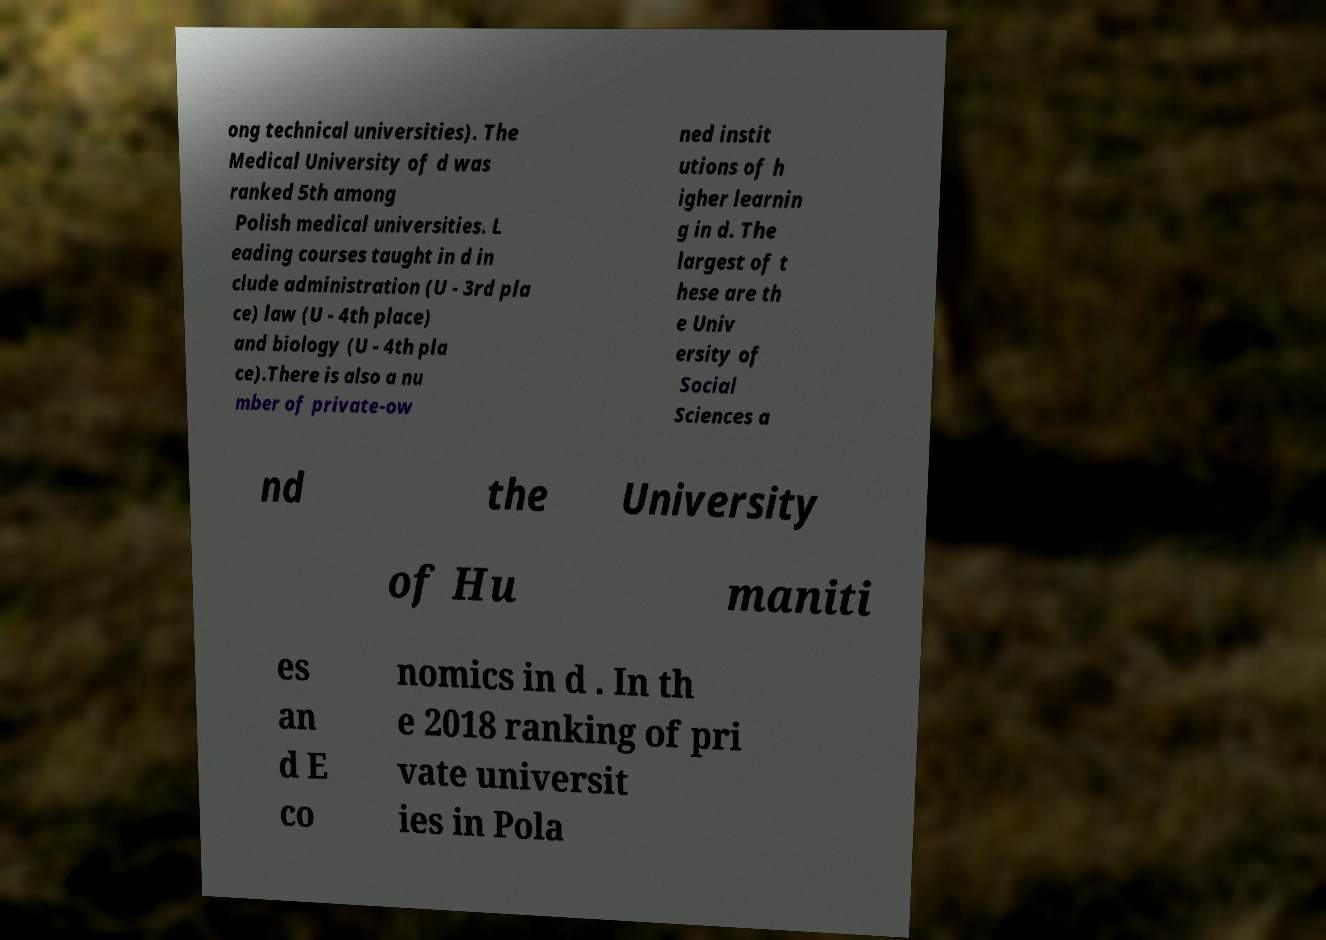I need the written content from this picture converted into text. Can you do that? ong technical universities). The Medical University of d was ranked 5th among Polish medical universities. L eading courses taught in d in clude administration (U - 3rd pla ce) law (U - 4th place) and biology (U - 4th pla ce).There is also a nu mber of private-ow ned instit utions of h igher learnin g in d. The largest of t hese are th e Univ ersity of Social Sciences a nd the University of Hu maniti es an d E co nomics in d . In th e 2018 ranking of pri vate universit ies in Pola 